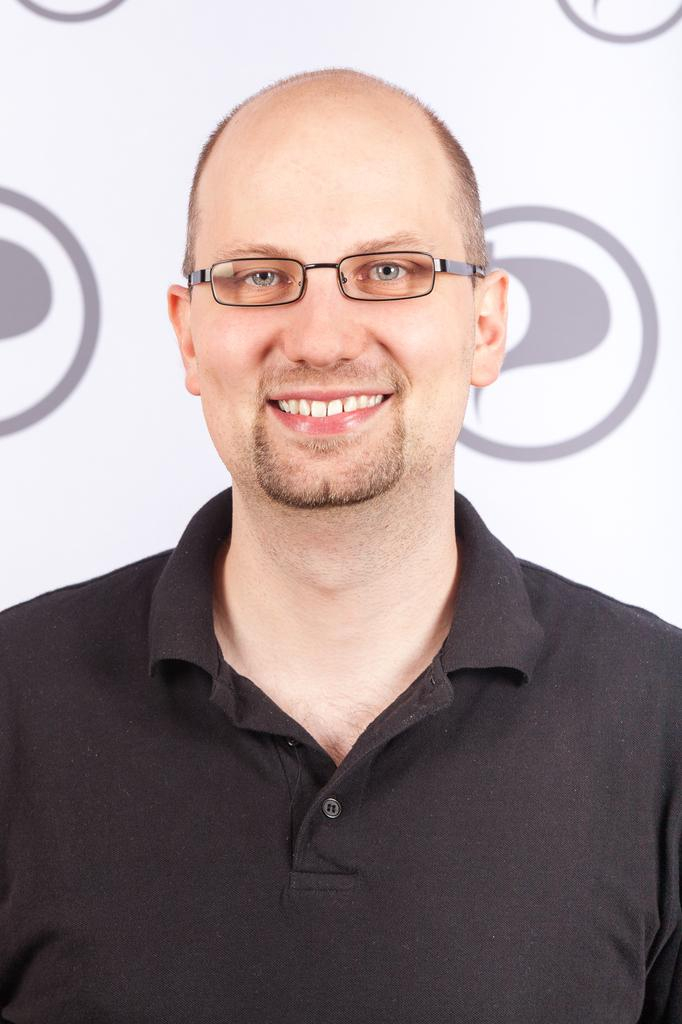Who is present in the image? There is a man in the image. What is the man wearing? The man is wearing spectacles. What is the man's facial expression? The man is smiling. What can be seen in the background of the image? There is a banner visible in the background of the image. What type of lunch is the man eating in the image? There is no lunch present in the image; the man is not eating anything. Why is the man crying in the image? The man is not crying in the image; he is smiling. 